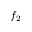<formula> <loc_0><loc_0><loc_500><loc_500>f _ { 2 }</formula> 